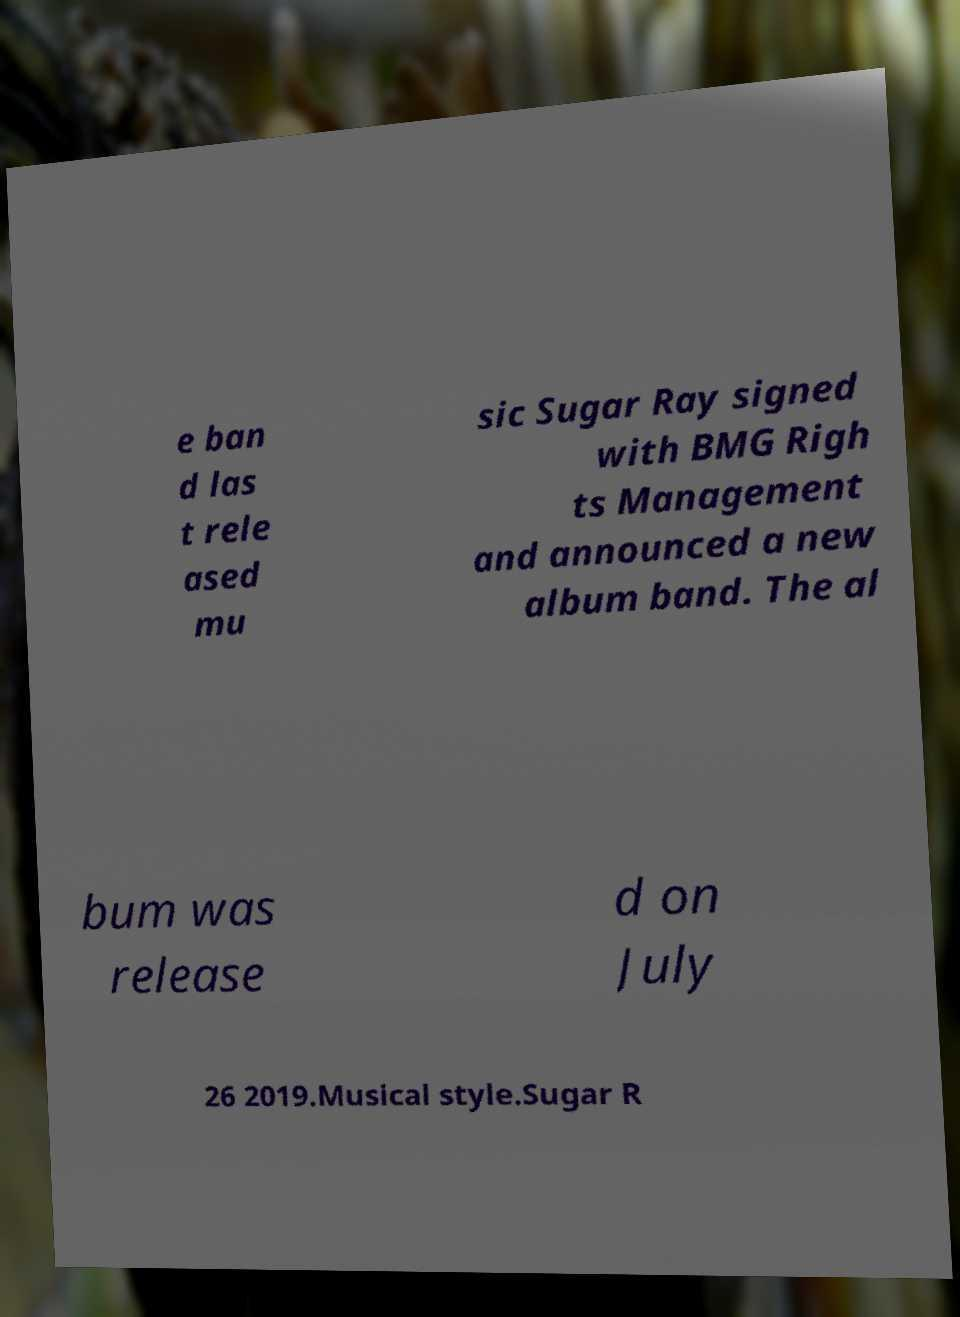Can you accurately transcribe the text from the provided image for me? e ban d las t rele ased mu sic Sugar Ray signed with BMG Righ ts Management and announced a new album band. The al bum was release d on July 26 2019.Musical style.Sugar R 